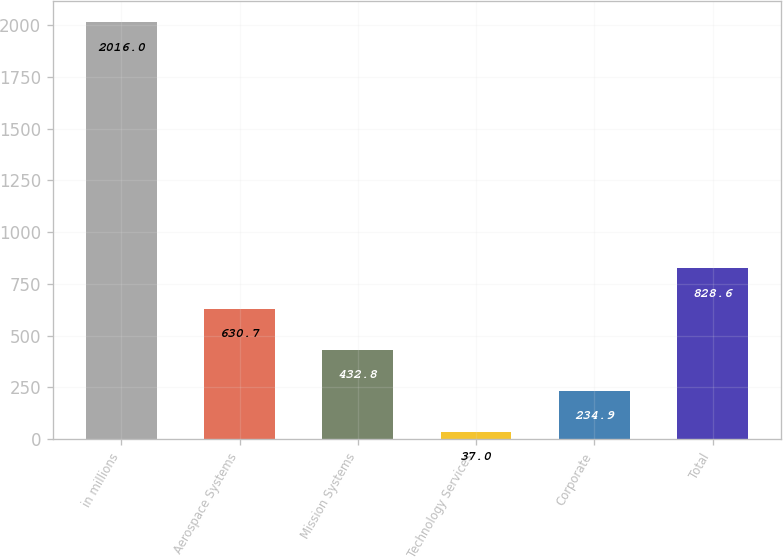Convert chart. <chart><loc_0><loc_0><loc_500><loc_500><bar_chart><fcel>in millions<fcel>Aerospace Systems<fcel>Mission Systems<fcel>Technology Services<fcel>Corporate<fcel>Total<nl><fcel>2016<fcel>630.7<fcel>432.8<fcel>37<fcel>234.9<fcel>828.6<nl></chart> 